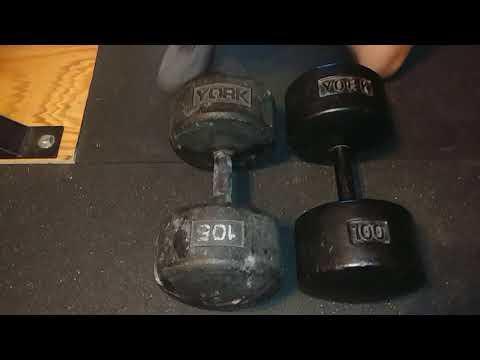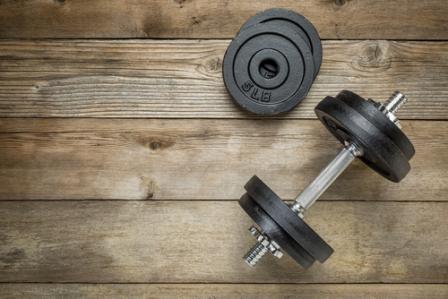The first image is the image on the left, the second image is the image on the right. Assess this claim about the two images: "All of the weights are round.". Correct or not? Answer yes or no. Yes. 